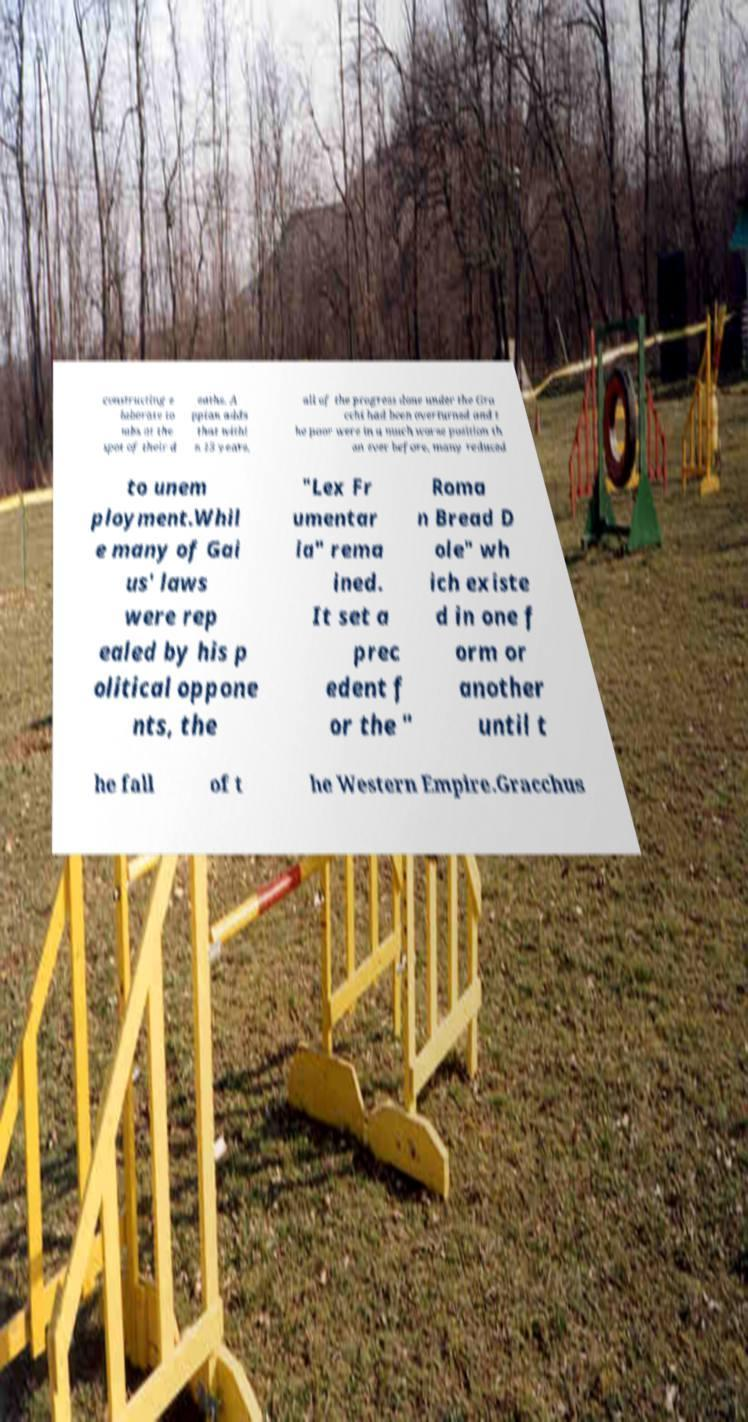For documentation purposes, I need the text within this image transcribed. Could you provide that? constructing e laborate to mbs at the spot of their d eaths. A ppian adds that withi n 15 years, all of the progress done under the Gra cchi had been overturned and t he poor were in a much worse position th an ever before, many reduced to unem ployment.Whil e many of Gai us' laws were rep ealed by his p olitical oppone nts, the "Lex Fr umentar ia" rema ined. It set a prec edent f or the " Roma n Bread D ole" wh ich existe d in one f orm or another until t he fall of t he Western Empire.Gracchus 